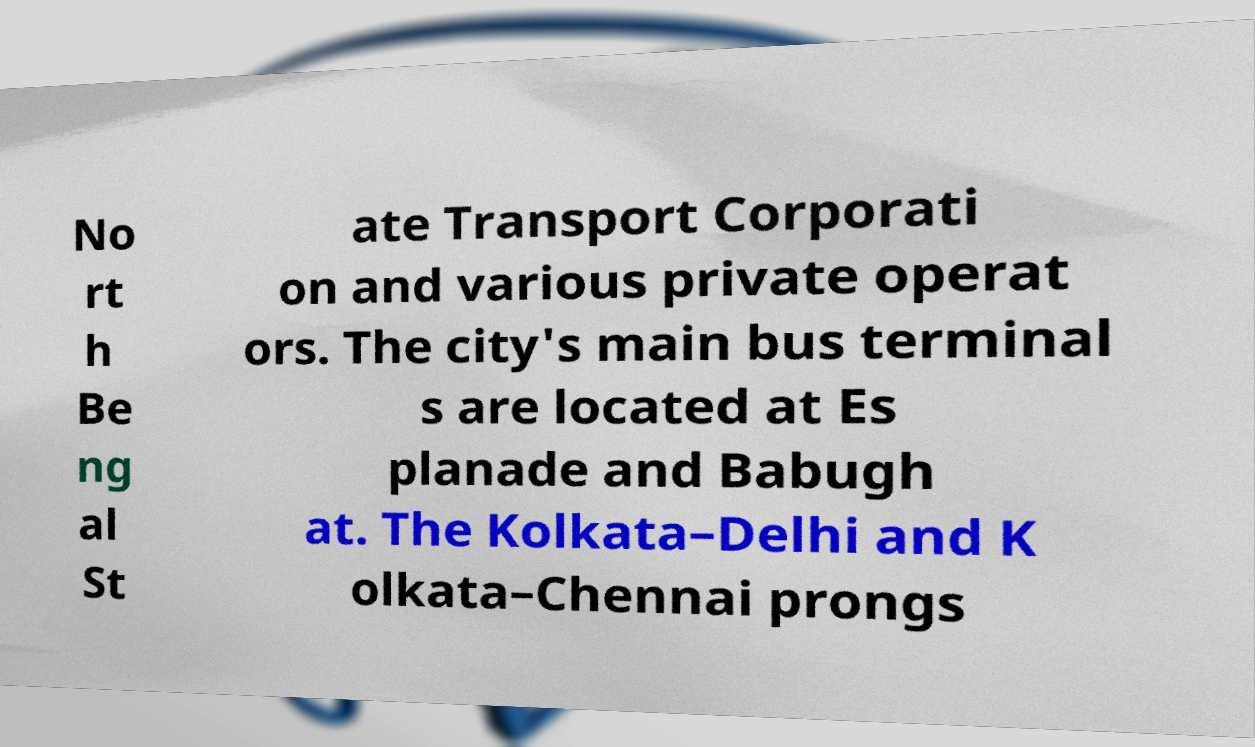What messages or text are displayed in this image? I need them in a readable, typed format. No rt h Be ng al St ate Transport Corporati on and various private operat ors. The city's main bus terminal s are located at Es planade and Babugh at. The Kolkata–Delhi and K olkata–Chennai prongs 